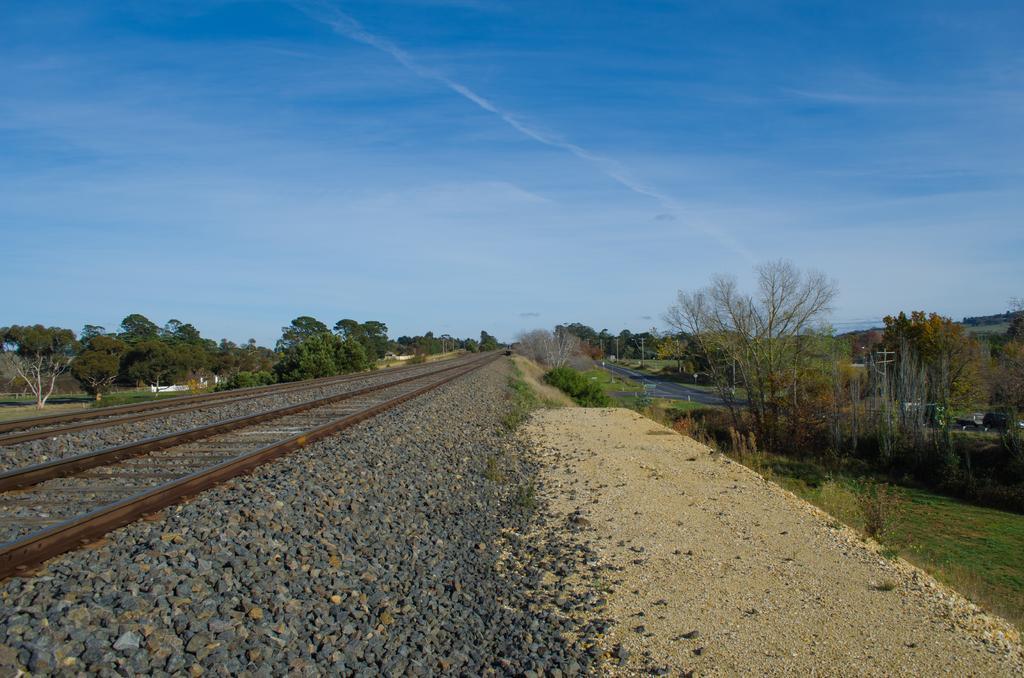Can you describe this image briefly? In the image we can see there is a railway track on the ground and there are lot of stones on the railway track. On both the sides there are lot of trees. 